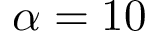Convert formula to latex. <formula><loc_0><loc_0><loc_500><loc_500>\alpha = 1 0</formula> 